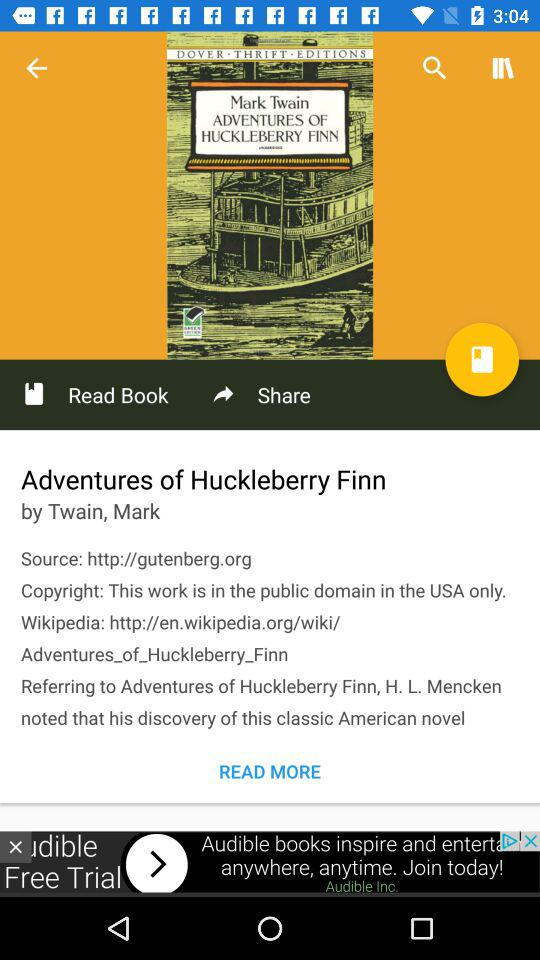To what domain does the book belong? The book belongs to the public domain. 